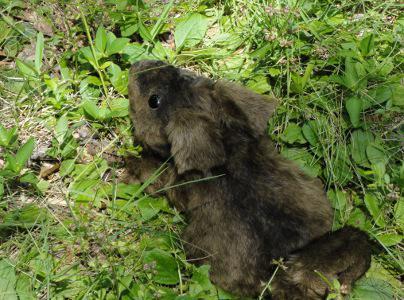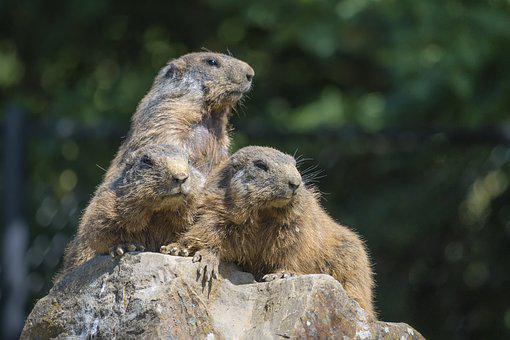The first image is the image on the left, the second image is the image on the right. Analyze the images presented: Is the assertion "The left and right image contains the same number of prairie dogs." valid? Answer yes or no. No. The first image is the image on the left, the second image is the image on the right. Evaluate the accuracy of this statement regarding the images: "At least three marmots are eating.". Is it true? Answer yes or no. No. 